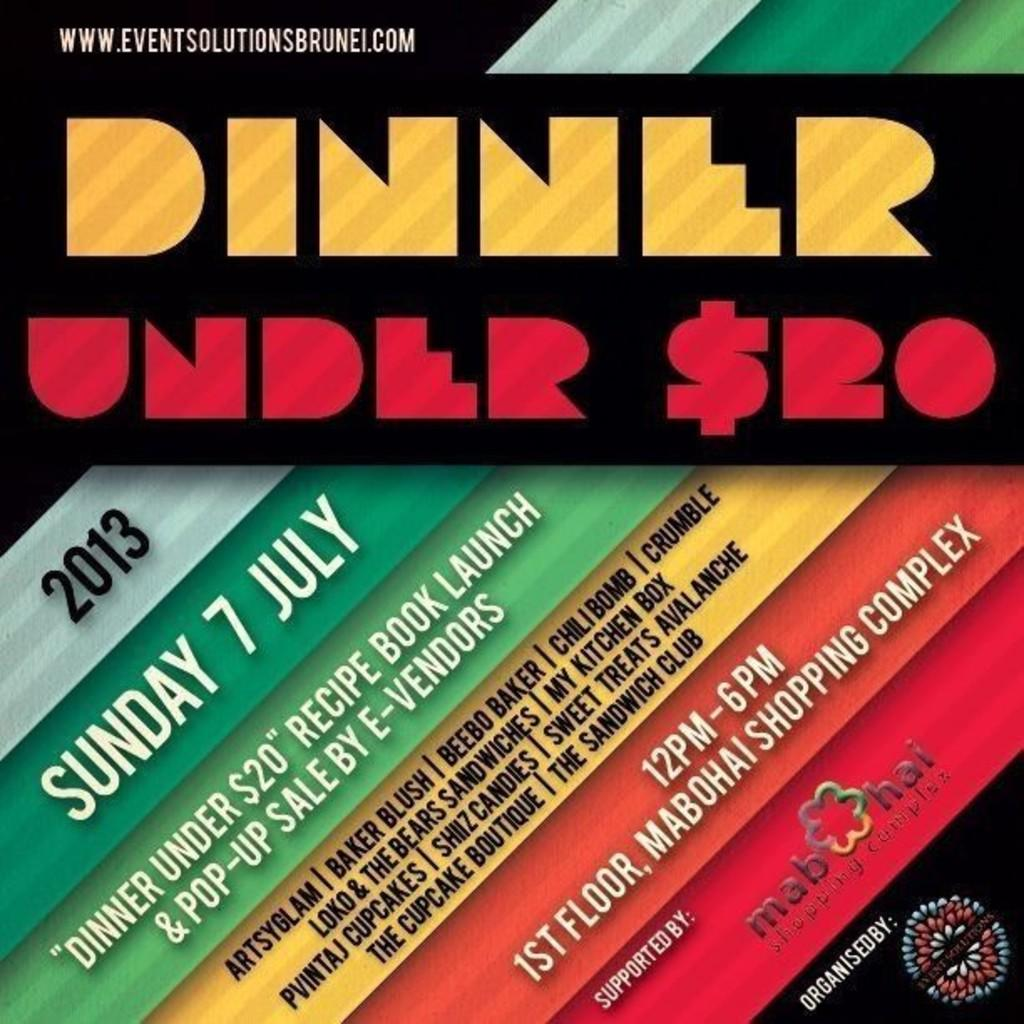What is the main subject of the image? The main subject of the image is an advertising poster. What can be found on the advertising poster? The poster contains text. How much sugar is present in the book mentioned on the poster? There is no book mentioned on the poster, and therefore no sugar content can be determined. 